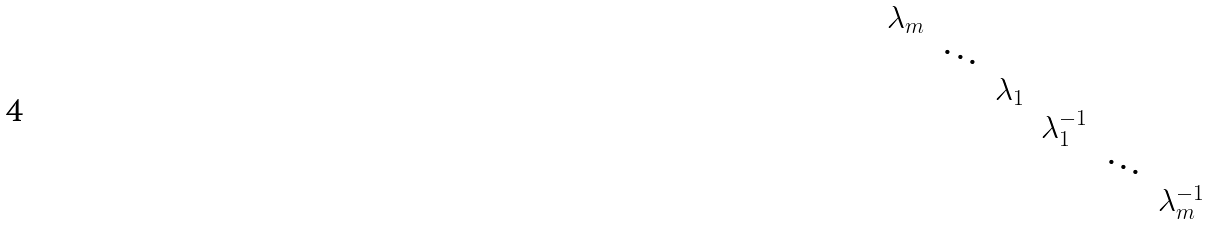<formula> <loc_0><loc_0><loc_500><loc_500>\begin{matrix} \lambda _ { m } & & & & & \\ & \ddots & & & & \\ & & \lambda _ { 1 } & & & \\ & & & \lambda _ { 1 } ^ { - 1 } & & \\ & & & & \ddots & \\ & & & & & \lambda _ { m } ^ { - 1 } \end{matrix}</formula> 